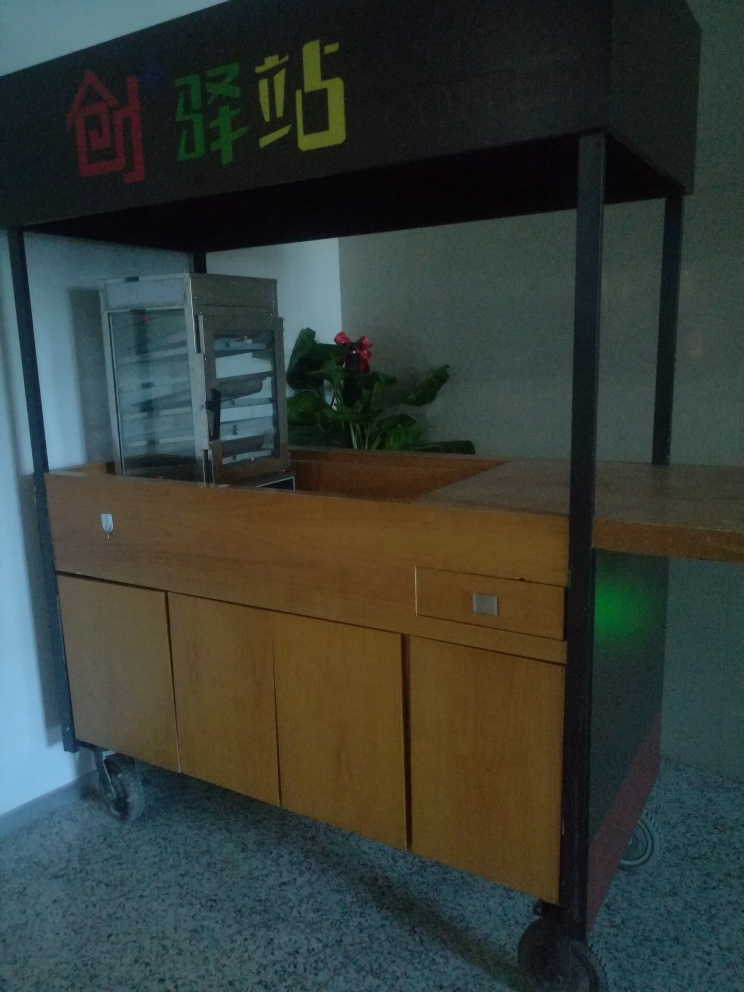What could the sign with colorful characters possibly indicate? The sign features stylized characters likely to be indicative of the name or type of food offered at this counter. It is colorful and prominently displayed above the counter, suggesting it's a place that wants to attract attention and convey a sense of branding or identity. Without knowing the exact language, it's difficult to provide a precise translation, but its design suggests it's part of a lively, casual establishment. 